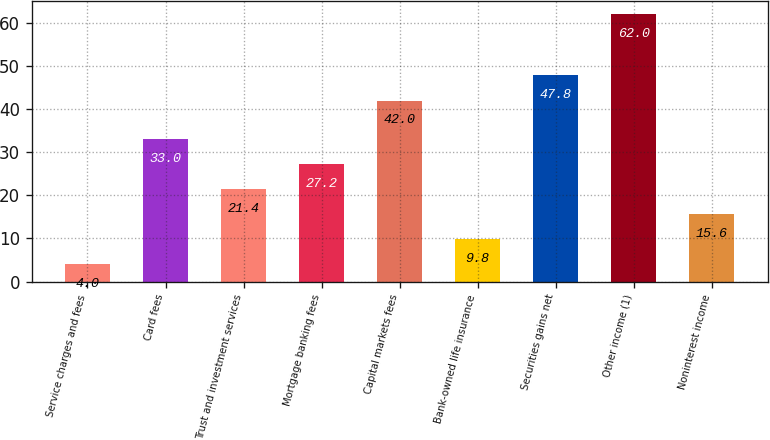Convert chart. <chart><loc_0><loc_0><loc_500><loc_500><bar_chart><fcel>Service charges and fees<fcel>Card fees<fcel>Trust and investment services<fcel>Mortgage banking fees<fcel>Capital markets fees<fcel>Bank-owned life insurance<fcel>Securities gains net<fcel>Other income (1)<fcel>Noninterest income<nl><fcel>4<fcel>33<fcel>21.4<fcel>27.2<fcel>42<fcel>9.8<fcel>47.8<fcel>62<fcel>15.6<nl></chart> 